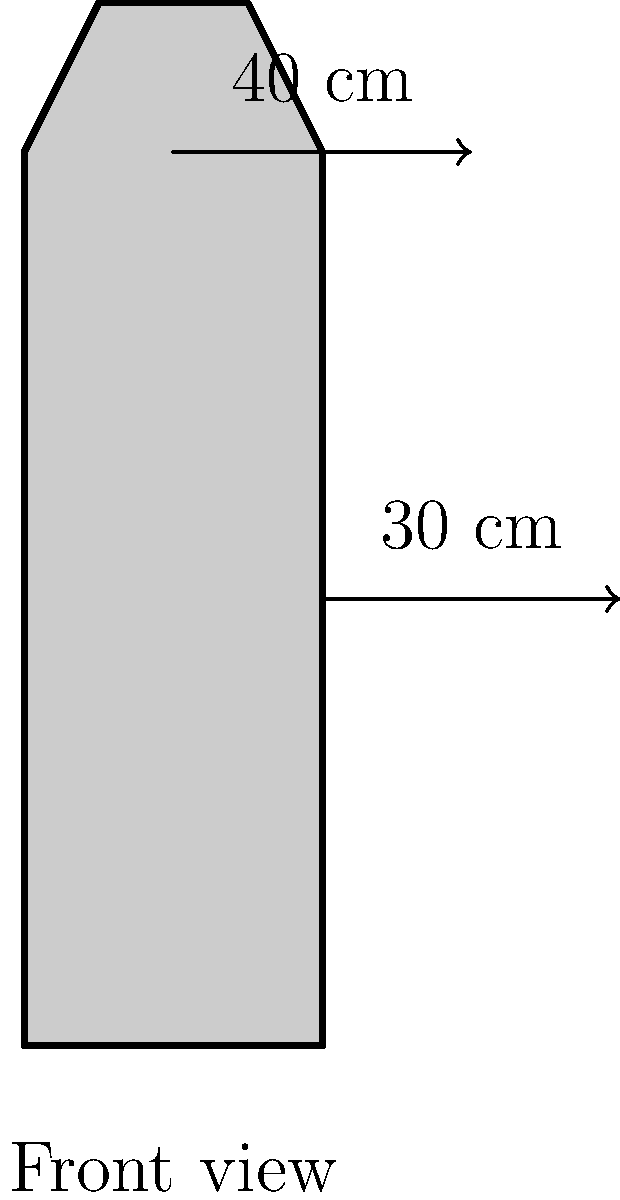You're designing a new DRR t-shirt using a simple human silhouette as shown in the diagram. The actual dimensions of the t-shirt are 40 cm in height and 30 cm in width. If you want to add a 2 cm margin on all sides for seam allowance, what's the minimum area of fabric needed for one t-shirt in square centimeters? Let's approach this step-by-step:

1. Understand the given dimensions:
   - Height of the t-shirt: 40 cm
   - Width of the t-shirt: 30 cm
   - Seam allowance: 2 cm on all sides

2. Calculate the total height with seam allowance:
   - Total height = Original height + (2 × Seam allowance)
   - Total height = 40 cm + (2 × 2 cm) = 44 cm

3. Calculate the total width with seam allowance:
   - Total width = Original width + (2 × Seam allowance)
   - Total width = 30 cm + (2 × 2 cm) = 34 cm

4. Calculate the area of fabric needed:
   - Area = Total height × Total width
   - Area = 44 cm × 34 cm = 1496 cm²

Therefore, the minimum area of fabric needed for one DRR t-shirt, including seam allowance, is 1496 square centimeters.
Answer: 1496 cm² 